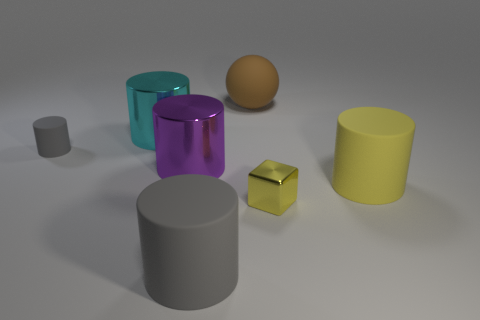Add 2 gray rubber cylinders. How many objects exist? 9 Subtract all yellow cylinders. How many cylinders are left? 4 Subtract all red spheres. How many gray cylinders are left? 2 Subtract all purple cylinders. How many cylinders are left? 4 Subtract all cubes. How many objects are left? 6 Add 6 large cyan metal cylinders. How many large cyan metal cylinders are left? 7 Add 2 tiny metallic things. How many tiny metallic things exist? 3 Subtract 0 blue balls. How many objects are left? 7 Subtract all yellow spheres. Subtract all yellow blocks. How many spheres are left? 1 Subtract all tiny red rubber cylinders. Subtract all large brown spheres. How many objects are left? 6 